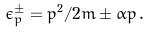Convert formula to latex. <formula><loc_0><loc_0><loc_500><loc_500>\epsilon _ { p } ^ { \pm } = p ^ { 2 } / 2 m \pm \alpha p \, .</formula> 